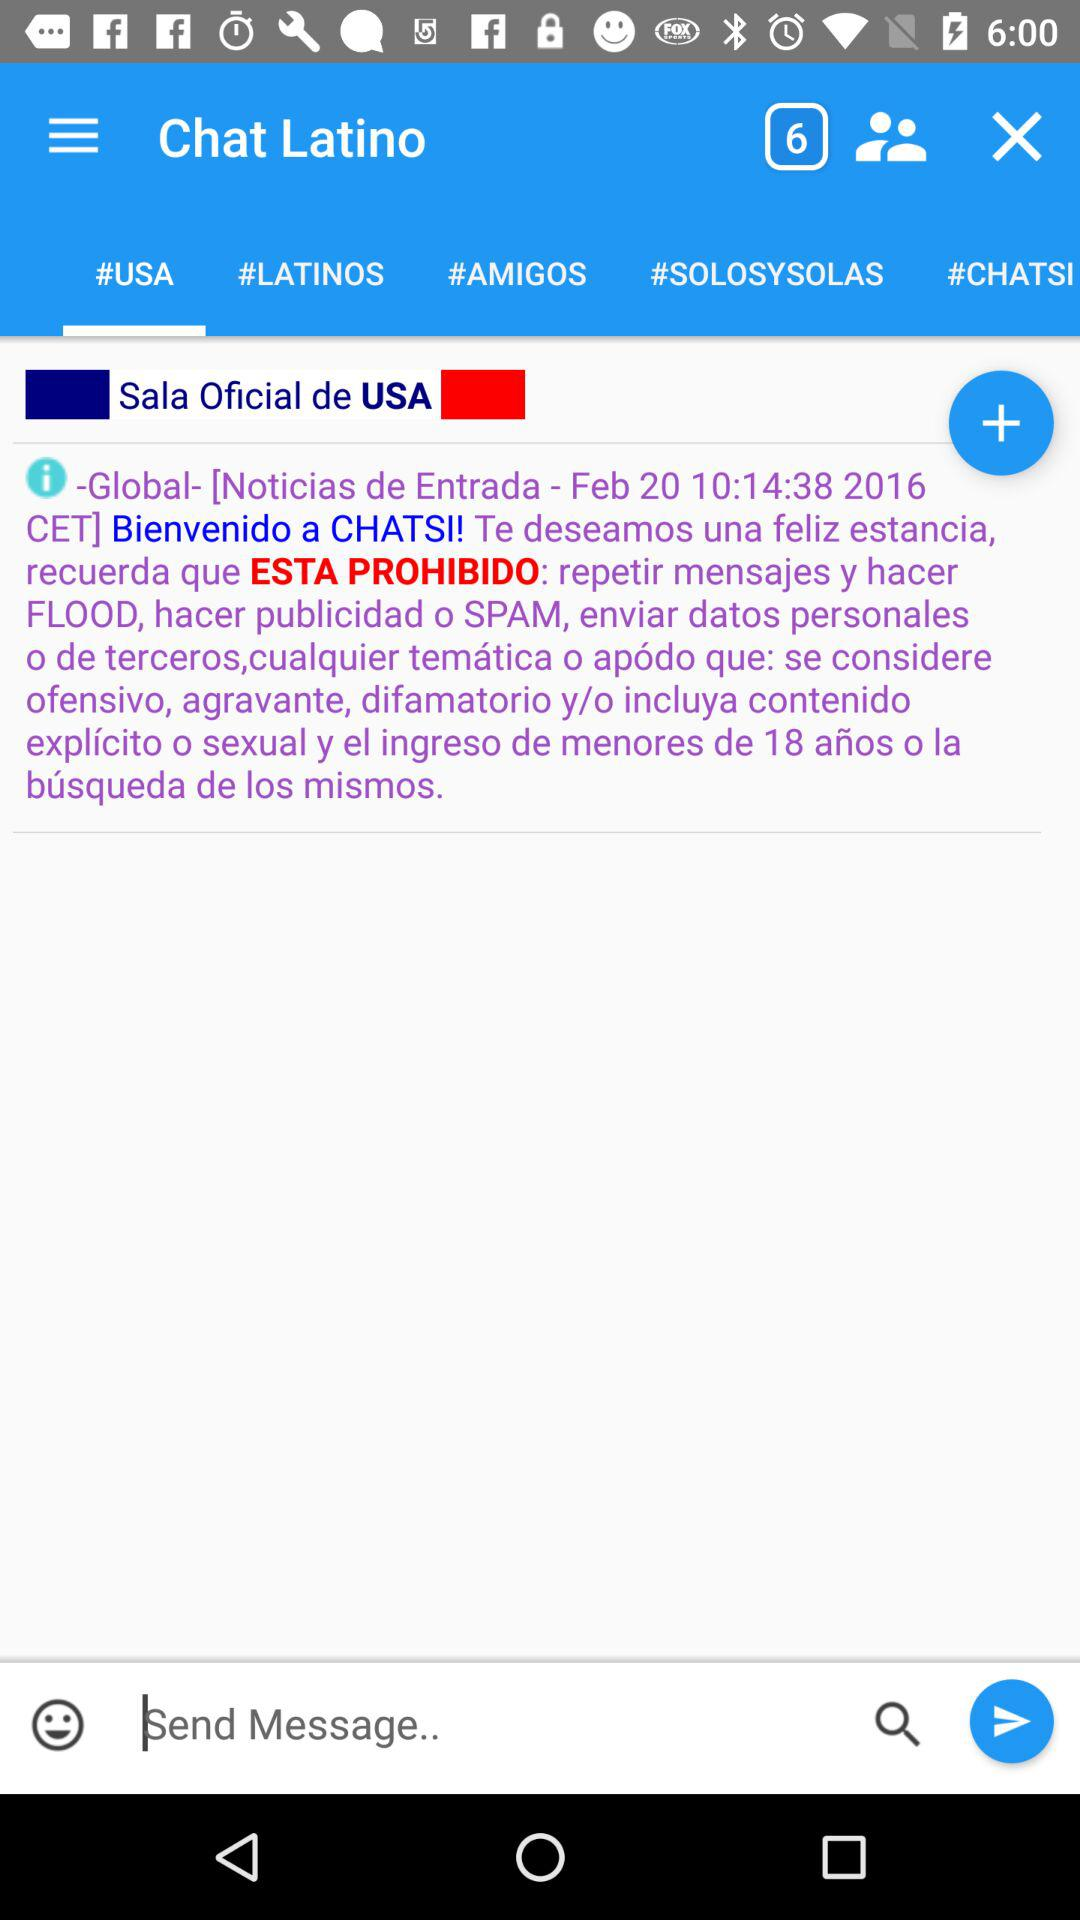Which tab am I on? You are on "#USA" tab. 